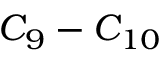<formula> <loc_0><loc_0><loc_500><loc_500>C _ { 9 } - C _ { 1 0 }</formula> 